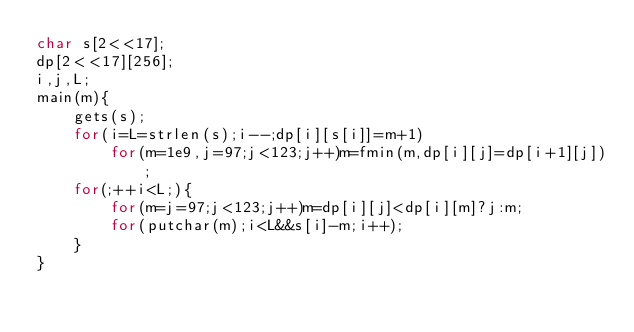Convert code to text. <code><loc_0><loc_0><loc_500><loc_500><_C_>char s[2<<17];
dp[2<<17][256];
i,j,L;
main(m){
	gets(s);
	for(i=L=strlen(s);i--;dp[i][s[i]]=m+1)
		for(m=1e9,j=97;j<123;j++)m=fmin(m,dp[i][j]=dp[i+1][j]);
	for(;++i<L;){
		for(m=j=97;j<123;j++)m=dp[i][j]<dp[i][m]?j:m;
		for(putchar(m);i<L&&s[i]-m;i++);
	}
}</code> 